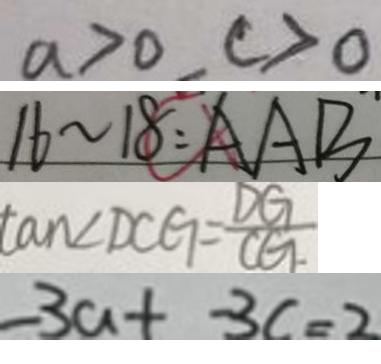<formula> <loc_0><loc_0><loc_500><loc_500>a > 0 , c > 0 
 1 6 \sim 1 8 = A A B 
 \tan \angle D C G = \frac { D G } { C G } 
 - 3 a - 3 c = 2</formula> 